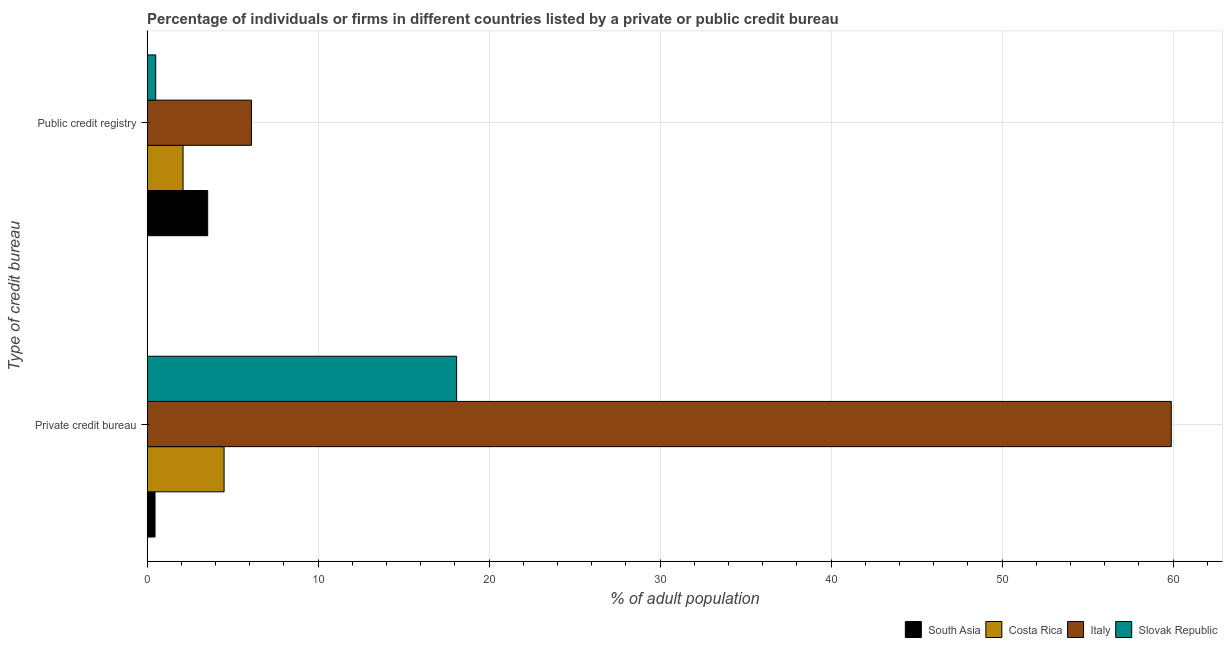How many groups of bars are there?
Your answer should be compact. 2. Are the number of bars per tick equal to the number of legend labels?
Make the answer very short. Yes. How many bars are there on the 2nd tick from the bottom?
Offer a terse response. 4. What is the label of the 1st group of bars from the top?
Provide a succinct answer. Public credit registry. What is the percentage of firms listed by private credit bureau in Costa Rica?
Offer a terse response. 4.5. Across all countries, what is the minimum percentage of firms listed by public credit bureau?
Make the answer very short. 0.5. In which country was the percentage of firms listed by public credit bureau minimum?
Your answer should be very brief. Slovak Republic. What is the total percentage of firms listed by public credit bureau in the graph?
Offer a terse response. 12.24. What is the difference between the percentage of firms listed by private credit bureau in Costa Rica and that in Slovak Republic?
Give a very brief answer. -13.6. What is the difference between the percentage of firms listed by public credit bureau in South Asia and the percentage of firms listed by private credit bureau in Slovak Republic?
Your answer should be very brief. -14.56. What is the average percentage of firms listed by public credit bureau per country?
Give a very brief answer. 3.06. What is the difference between the percentage of firms listed by private credit bureau and percentage of firms listed by public credit bureau in South Asia?
Your answer should be compact. -3.08. In how many countries, is the percentage of firms listed by private credit bureau greater than 26 %?
Make the answer very short. 1. What is the ratio of the percentage of firms listed by private credit bureau in Italy to that in Costa Rica?
Offer a very short reply. 13.31. What does the 1st bar from the top in Public credit registry represents?
Your answer should be compact. Slovak Republic. How many bars are there?
Give a very brief answer. 8. Are the values on the major ticks of X-axis written in scientific E-notation?
Give a very brief answer. No. Does the graph contain any zero values?
Provide a short and direct response. No. Does the graph contain grids?
Your answer should be compact. Yes. How many legend labels are there?
Provide a succinct answer. 4. What is the title of the graph?
Offer a terse response. Percentage of individuals or firms in different countries listed by a private or public credit bureau. What is the label or title of the X-axis?
Ensure brevity in your answer.  % of adult population. What is the label or title of the Y-axis?
Ensure brevity in your answer.  Type of credit bureau. What is the % of adult population in South Asia in Private credit bureau?
Ensure brevity in your answer.  0.46. What is the % of adult population in Italy in Private credit bureau?
Give a very brief answer. 59.9. What is the % of adult population in Slovak Republic in Private credit bureau?
Make the answer very short. 18.1. What is the % of adult population of South Asia in Public credit registry?
Provide a short and direct response. 3.54. What is the % of adult population in Costa Rica in Public credit registry?
Offer a very short reply. 2.1. What is the % of adult population of Italy in Public credit registry?
Give a very brief answer. 6.1. What is the % of adult population in Slovak Republic in Public credit registry?
Give a very brief answer. 0.5. Across all Type of credit bureau, what is the maximum % of adult population in South Asia?
Offer a terse response. 3.54. Across all Type of credit bureau, what is the maximum % of adult population of Costa Rica?
Make the answer very short. 4.5. Across all Type of credit bureau, what is the maximum % of adult population of Italy?
Your response must be concise. 59.9. Across all Type of credit bureau, what is the maximum % of adult population in Slovak Republic?
Make the answer very short. 18.1. Across all Type of credit bureau, what is the minimum % of adult population in South Asia?
Keep it short and to the point. 0.46. Across all Type of credit bureau, what is the minimum % of adult population in Costa Rica?
Your answer should be very brief. 2.1. Across all Type of credit bureau, what is the minimum % of adult population in Italy?
Ensure brevity in your answer.  6.1. Across all Type of credit bureau, what is the minimum % of adult population in Slovak Republic?
Your answer should be very brief. 0.5. What is the total % of adult population of South Asia in the graph?
Provide a short and direct response. 4. What is the difference between the % of adult population of South Asia in Private credit bureau and that in Public credit registry?
Give a very brief answer. -3.08. What is the difference between the % of adult population in Costa Rica in Private credit bureau and that in Public credit registry?
Keep it short and to the point. 2.4. What is the difference between the % of adult population in Italy in Private credit bureau and that in Public credit registry?
Make the answer very short. 53.8. What is the difference between the % of adult population in Slovak Republic in Private credit bureau and that in Public credit registry?
Offer a terse response. 17.6. What is the difference between the % of adult population in South Asia in Private credit bureau and the % of adult population in Costa Rica in Public credit registry?
Your response must be concise. -1.64. What is the difference between the % of adult population of South Asia in Private credit bureau and the % of adult population of Italy in Public credit registry?
Ensure brevity in your answer.  -5.64. What is the difference between the % of adult population in South Asia in Private credit bureau and the % of adult population in Slovak Republic in Public credit registry?
Give a very brief answer. -0.04. What is the difference between the % of adult population in Italy in Private credit bureau and the % of adult population in Slovak Republic in Public credit registry?
Ensure brevity in your answer.  59.4. What is the average % of adult population of South Asia per Type of credit bureau?
Provide a succinct answer. 2. What is the average % of adult population in Costa Rica per Type of credit bureau?
Give a very brief answer. 3.3. What is the difference between the % of adult population of South Asia and % of adult population of Costa Rica in Private credit bureau?
Offer a terse response. -4.04. What is the difference between the % of adult population in South Asia and % of adult population in Italy in Private credit bureau?
Your answer should be compact. -59.44. What is the difference between the % of adult population of South Asia and % of adult population of Slovak Republic in Private credit bureau?
Provide a short and direct response. -17.64. What is the difference between the % of adult population of Costa Rica and % of adult population of Italy in Private credit bureau?
Give a very brief answer. -55.4. What is the difference between the % of adult population of Italy and % of adult population of Slovak Republic in Private credit bureau?
Keep it short and to the point. 41.8. What is the difference between the % of adult population of South Asia and % of adult population of Costa Rica in Public credit registry?
Provide a short and direct response. 1.44. What is the difference between the % of adult population of South Asia and % of adult population of Italy in Public credit registry?
Give a very brief answer. -2.56. What is the difference between the % of adult population of South Asia and % of adult population of Slovak Republic in Public credit registry?
Your response must be concise. 3.04. What is the ratio of the % of adult population in South Asia in Private credit bureau to that in Public credit registry?
Your answer should be very brief. 0.13. What is the ratio of the % of adult population of Costa Rica in Private credit bureau to that in Public credit registry?
Provide a short and direct response. 2.14. What is the ratio of the % of adult population of Italy in Private credit bureau to that in Public credit registry?
Ensure brevity in your answer.  9.82. What is the ratio of the % of adult population in Slovak Republic in Private credit bureau to that in Public credit registry?
Offer a terse response. 36.2. What is the difference between the highest and the second highest % of adult population of South Asia?
Ensure brevity in your answer.  3.08. What is the difference between the highest and the second highest % of adult population in Costa Rica?
Keep it short and to the point. 2.4. What is the difference between the highest and the second highest % of adult population of Italy?
Provide a succinct answer. 53.8. What is the difference between the highest and the second highest % of adult population of Slovak Republic?
Offer a terse response. 17.6. What is the difference between the highest and the lowest % of adult population in South Asia?
Provide a succinct answer. 3.08. What is the difference between the highest and the lowest % of adult population of Italy?
Your answer should be very brief. 53.8. 